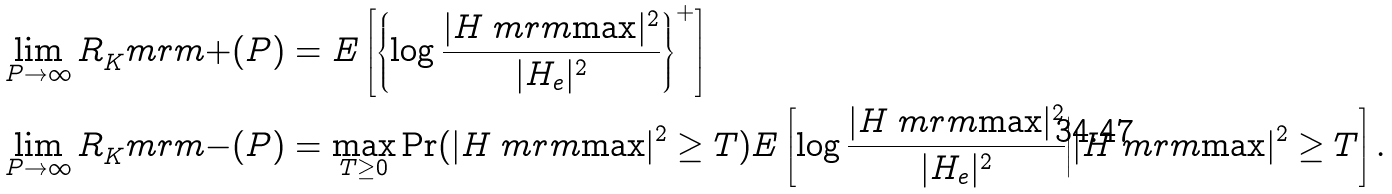Convert formula to latex. <formula><loc_0><loc_0><loc_500><loc_500>\lim _ { P \rightarrow \infty } R _ { K } ^ { \ } m r m { + } ( P ) & = E \left [ \left \{ \log \frac { | H _ { \ } m r m { \max } | ^ { 2 } } { | H _ { e } | ^ { 2 } } \right \} ^ { + } \right ] \\ \lim _ { P \rightarrow \infty } R _ { K } ^ { \ } m r m { - } ( P ) & = \max _ { T \geq 0 } \Pr ( | H _ { \ } m r m { \max } | ^ { 2 } \geq T ) E \left [ \log \frac { | H _ { \ } m r m { \max } | ^ { 2 } } { | H _ { e } | ^ { 2 } } \Big | | H _ { \ } m r m { \max } | ^ { 2 } \geq T \right ] .</formula> 